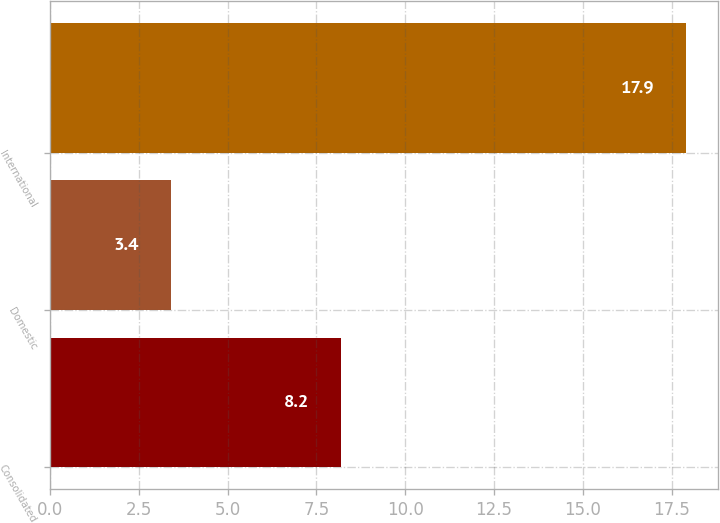<chart> <loc_0><loc_0><loc_500><loc_500><bar_chart><fcel>Consolidated<fcel>Domestic<fcel>International<nl><fcel>8.2<fcel>3.4<fcel>17.9<nl></chart> 